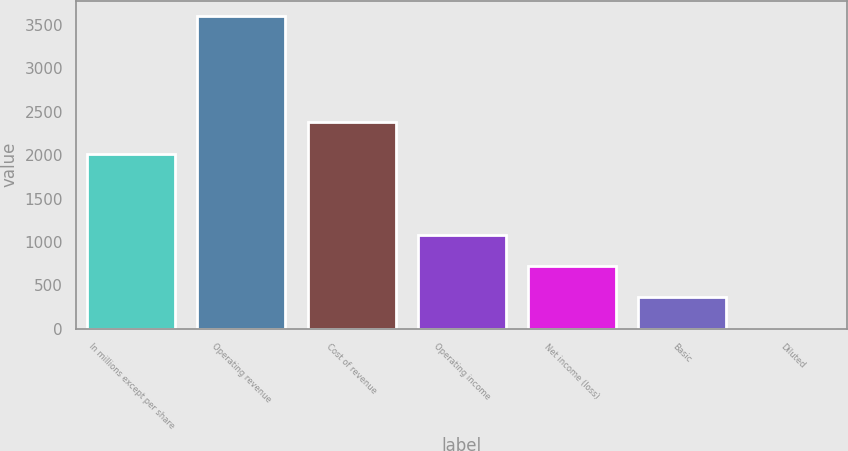Convert chart. <chart><loc_0><loc_0><loc_500><loc_500><bar_chart><fcel>In millions except per share<fcel>Operating revenue<fcel>Cost of revenue<fcel>Operating income<fcel>Net income (loss)<fcel>Basic<fcel>Diluted<nl><fcel>2017<fcel>3599<fcel>2376.73<fcel>1080.88<fcel>721.15<fcel>361.42<fcel>1.69<nl></chart> 